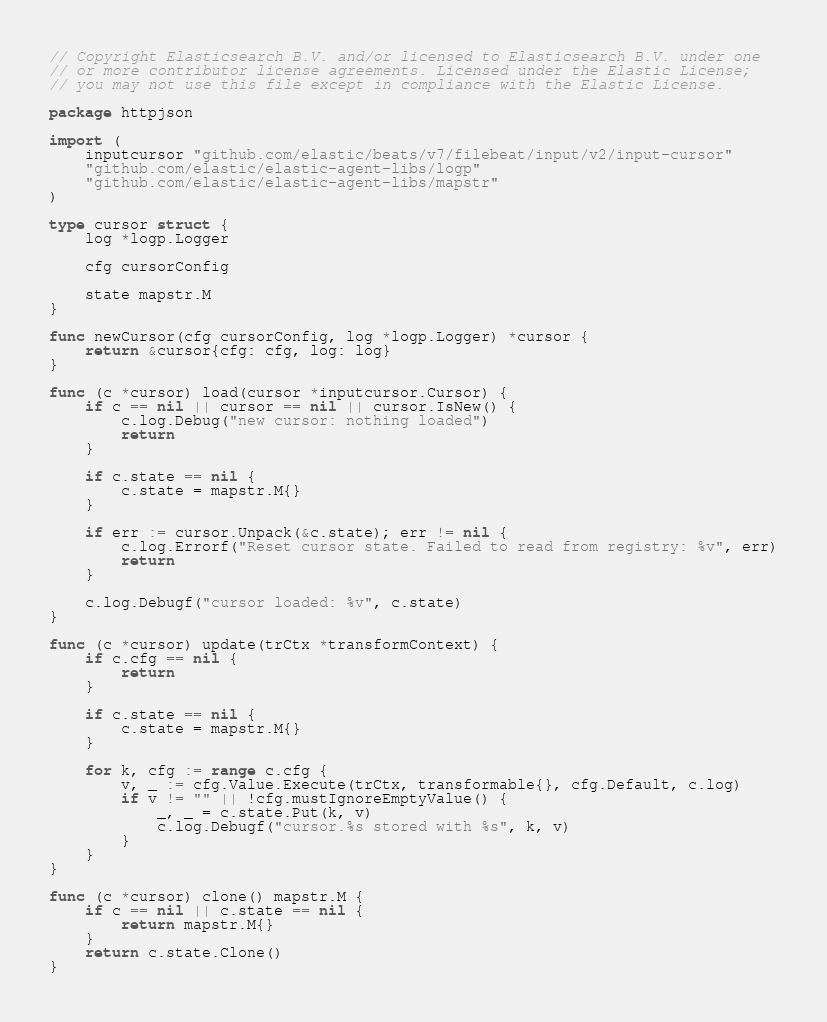Convert code to text. <code><loc_0><loc_0><loc_500><loc_500><_Go_>// Copyright Elasticsearch B.V. and/or licensed to Elasticsearch B.V. under one
// or more contributor license agreements. Licensed under the Elastic License;
// you may not use this file except in compliance with the Elastic License.

package httpjson

import (
	inputcursor "github.com/elastic/beats/v7/filebeat/input/v2/input-cursor"
	"github.com/elastic/elastic-agent-libs/logp"
	"github.com/elastic/elastic-agent-libs/mapstr"
)

type cursor struct {
	log *logp.Logger

	cfg cursorConfig

	state mapstr.M
}

func newCursor(cfg cursorConfig, log *logp.Logger) *cursor {
	return &cursor{cfg: cfg, log: log}
}

func (c *cursor) load(cursor *inputcursor.Cursor) {
	if c == nil || cursor == nil || cursor.IsNew() {
		c.log.Debug("new cursor: nothing loaded")
		return
	}

	if c.state == nil {
		c.state = mapstr.M{}
	}

	if err := cursor.Unpack(&c.state); err != nil {
		c.log.Errorf("Reset cursor state. Failed to read from registry: %v", err)
		return
	}

	c.log.Debugf("cursor loaded: %v", c.state)
}

func (c *cursor) update(trCtx *transformContext) {
	if c.cfg == nil {
		return
	}

	if c.state == nil {
		c.state = mapstr.M{}
	}

	for k, cfg := range c.cfg {
		v, _ := cfg.Value.Execute(trCtx, transformable{}, cfg.Default, c.log)
		if v != "" || !cfg.mustIgnoreEmptyValue() {
			_, _ = c.state.Put(k, v)
			c.log.Debugf("cursor.%s stored with %s", k, v)
		}
	}
}

func (c *cursor) clone() mapstr.M {
	if c == nil || c.state == nil {
		return mapstr.M{}
	}
	return c.state.Clone()
}
</code> 